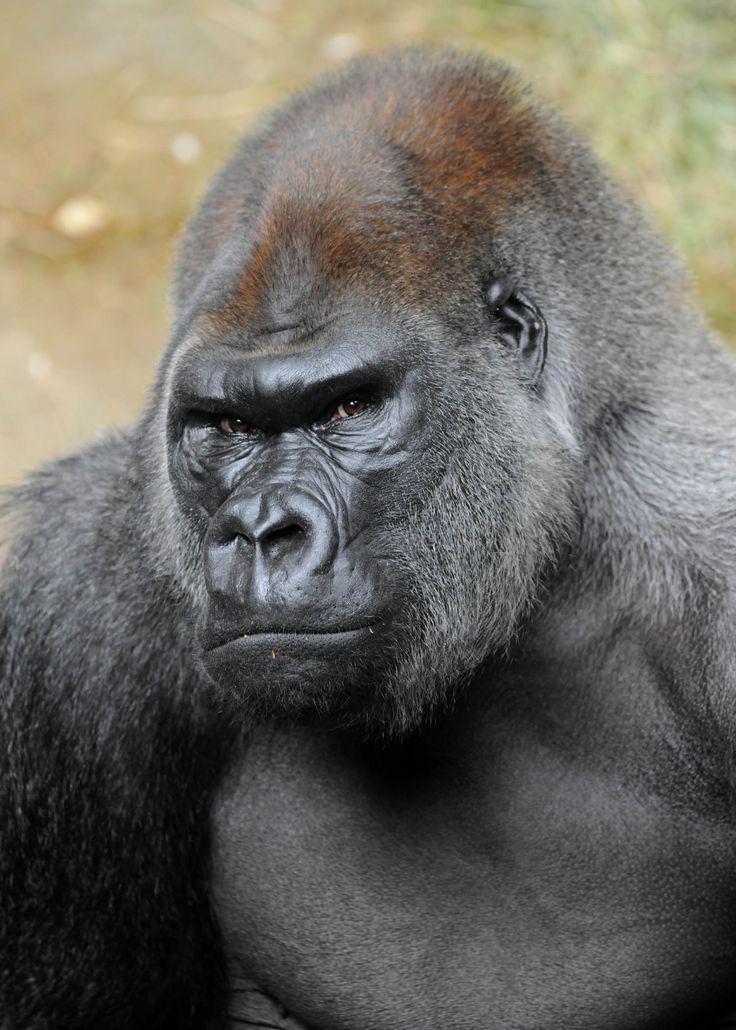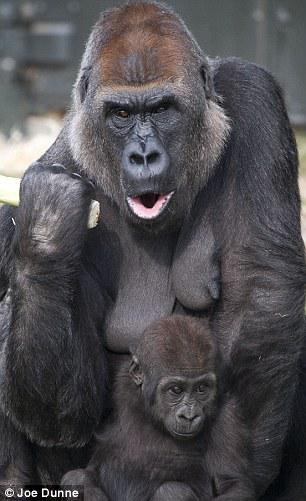The first image is the image on the left, the second image is the image on the right. Evaluate the accuracy of this statement regarding the images: "In at least one image there is a gorilla with his mouth wide open.". Is it true? Answer yes or no. Yes. The first image is the image on the left, the second image is the image on the right. Evaluate the accuracy of this statement regarding the images: "An ape has its mouth open.". Is it true? Answer yes or no. Yes. 